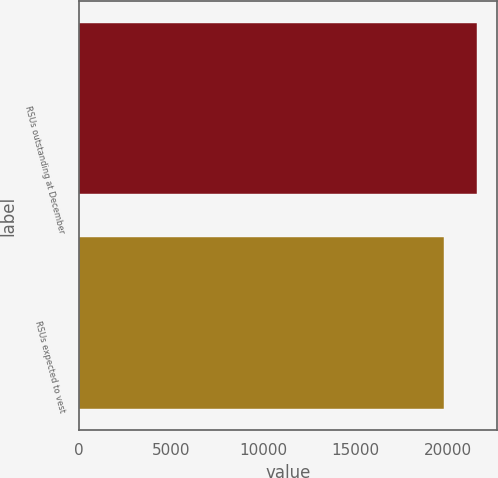Convert chart. <chart><loc_0><loc_0><loc_500><loc_500><bar_chart><fcel>RSUs outstanding at December<fcel>RSUs expected to vest<nl><fcel>21571<fcel>19773<nl></chart> 